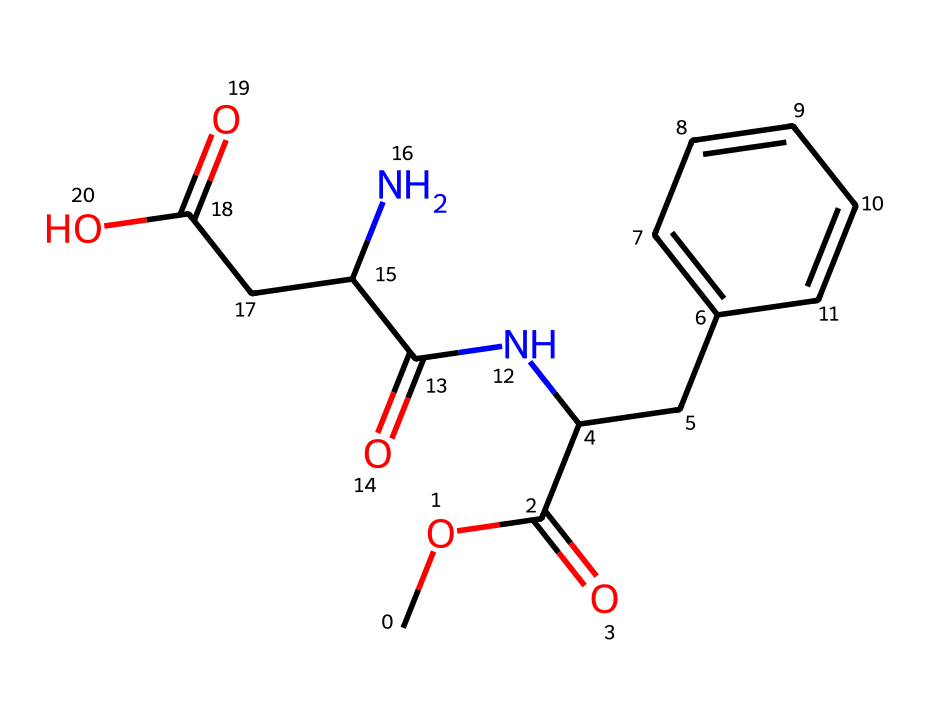How many carbon atoms are present in this molecule? Counting the carbon (C) symbols in the SMILES representation, there are a total of 9 carbon atoms indicated.
Answer: 9 What is the functional group present in this chemical that indicates it is a carbohydrate? The presence of multiple hydroxyl (-OH) groups, along with carbonyl functions, indicates characteristics of carbohydrates. In this structure, there is a carboxylic acid (-COOH) that supports this classification.
Answer: carboxylic acid How many rings are present in the structure? Observing the structure, there is one ring evident where the phenyl group is located, which is identified by the 'CC1=CC=CC=C1' part in the SMILES representation.
Answer: 1 What type of bond appears most frequently in this molecule? By examining the structural components, single bonds and double bonds are present, but the carbon-carbon single bonds are the most abundant.
Answer: single bond What additional elements are present in this molecule aside from carbon? The SMILES indicates the presence of nitrogen (N) and oxygen (O) along with the carbon atoms, highlighting the diverse elemental composition.
Answer: nitrogen, oxygen Which part of the molecule contributes to its sweetness? The N-acyl group and its attachment to the aromatic ring, along with both the presence of a phenyl group and specific functional groups, are known to contribute to the sweetness.
Answer: N-acyl group What is the total number of oxygen atoms in this molecule? By counting the oxygen (O) symbols in the SMILES notation, it is observed that there are 4 oxygen atoms present throughout the entire structure.
Answer: 4 